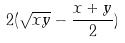<formula> <loc_0><loc_0><loc_500><loc_500>2 ( \sqrt { x y } - \frac { x + y } { 2 } )</formula> 